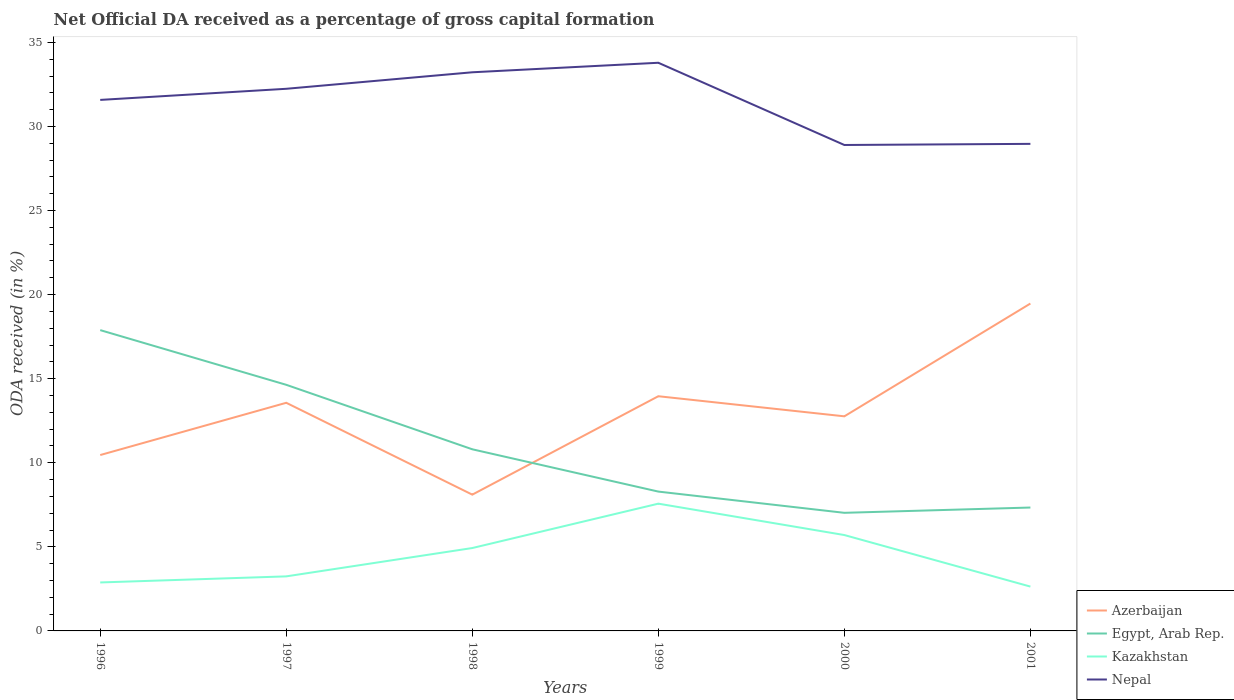Does the line corresponding to Egypt, Arab Rep. intersect with the line corresponding to Nepal?
Keep it short and to the point. No. Across all years, what is the maximum net ODA received in Nepal?
Your answer should be very brief. 28.9. In which year was the net ODA received in Egypt, Arab Rep. maximum?
Offer a very short reply. 2000. What is the total net ODA received in Nepal in the graph?
Your answer should be very brief. -0.57. What is the difference between the highest and the second highest net ODA received in Azerbaijan?
Your answer should be very brief. 11.37. What is the difference between the highest and the lowest net ODA received in Nepal?
Your response must be concise. 4. How many lines are there?
Give a very brief answer. 4. What is the difference between two consecutive major ticks on the Y-axis?
Ensure brevity in your answer.  5. Does the graph contain grids?
Your answer should be very brief. No. How many legend labels are there?
Provide a succinct answer. 4. What is the title of the graph?
Ensure brevity in your answer.  Net Official DA received as a percentage of gross capital formation. What is the label or title of the X-axis?
Ensure brevity in your answer.  Years. What is the label or title of the Y-axis?
Your response must be concise. ODA received (in %). What is the ODA received (in %) in Azerbaijan in 1996?
Your answer should be compact. 10.46. What is the ODA received (in %) in Egypt, Arab Rep. in 1996?
Ensure brevity in your answer.  17.89. What is the ODA received (in %) of Kazakhstan in 1996?
Give a very brief answer. 2.88. What is the ODA received (in %) in Nepal in 1996?
Your answer should be very brief. 31.58. What is the ODA received (in %) in Azerbaijan in 1997?
Provide a short and direct response. 13.57. What is the ODA received (in %) of Egypt, Arab Rep. in 1997?
Your answer should be very brief. 14.64. What is the ODA received (in %) in Kazakhstan in 1997?
Your answer should be very brief. 3.24. What is the ODA received (in %) in Nepal in 1997?
Provide a short and direct response. 32.24. What is the ODA received (in %) of Azerbaijan in 1998?
Your answer should be compact. 8.1. What is the ODA received (in %) in Egypt, Arab Rep. in 1998?
Your answer should be very brief. 10.8. What is the ODA received (in %) in Kazakhstan in 1998?
Provide a succinct answer. 4.93. What is the ODA received (in %) of Nepal in 1998?
Offer a terse response. 33.22. What is the ODA received (in %) in Azerbaijan in 1999?
Provide a succinct answer. 13.96. What is the ODA received (in %) of Egypt, Arab Rep. in 1999?
Your response must be concise. 8.29. What is the ODA received (in %) in Kazakhstan in 1999?
Provide a short and direct response. 7.57. What is the ODA received (in %) of Nepal in 1999?
Keep it short and to the point. 33.79. What is the ODA received (in %) of Azerbaijan in 2000?
Provide a succinct answer. 12.76. What is the ODA received (in %) in Egypt, Arab Rep. in 2000?
Provide a short and direct response. 7.02. What is the ODA received (in %) of Kazakhstan in 2000?
Make the answer very short. 5.7. What is the ODA received (in %) in Nepal in 2000?
Provide a succinct answer. 28.9. What is the ODA received (in %) in Azerbaijan in 2001?
Offer a terse response. 19.47. What is the ODA received (in %) of Egypt, Arab Rep. in 2001?
Provide a succinct answer. 7.34. What is the ODA received (in %) in Kazakhstan in 2001?
Give a very brief answer. 2.64. What is the ODA received (in %) of Nepal in 2001?
Offer a very short reply. 28.97. Across all years, what is the maximum ODA received (in %) in Azerbaijan?
Your answer should be very brief. 19.47. Across all years, what is the maximum ODA received (in %) in Egypt, Arab Rep.?
Your response must be concise. 17.89. Across all years, what is the maximum ODA received (in %) in Kazakhstan?
Your response must be concise. 7.57. Across all years, what is the maximum ODA received (in %) in Nepal?
Your answer should be compact. 33.79. Across all years, what is the minimum ODA received (in %) of Azerbaijan?
Your answer should be very brief. 8.1. Across all years, what is the minimum ODA received (in %) of Egypt, Arab Rep.?
Ensure brevity in your answer.  7.02. Across all years, what is the minimum ODA received (in %) of Kazakhstan?
Your answer should be very brief. 2.64. Across all years, what is the minimum ODA received (in %) of Nepal?
Provide a succinct answer. 28.9. What is the total ODA received (in %) in Azerbaijan in the graph?
Provide a succinct answer. 78.32. What is the total ODA received (in %) in Egypt, Arab Rep. in the graph?
Give a very brief answer. 65.98. What is the total ODA received (in %) of Kazakhstan in the graph?
Ensure brevity in your answer.  26.96. What is the total ODA received (in %) in Nepal in the graph?
Provide a succinct answer. 188.7. What is the difference between the ODA received (in %) in Azerbaijan in 1996 and that in 1997?
Ensure brevity in your answer.  -3.11. What is the difference between the ODA received (in %) of Egypt, Arab Rep. in 1996 and that in 1997?
Your answer should be very brief. 3.25. What is the difference between the ODA received (in %) in Kazakhstan in 1996 and that in 1997?
Provide a succinct answer. -0.36. What is the difference between the ODA received (in %) of Nepal in 1996 and that in 1997?
Make the answer very short. -0.66. What is the difference between the ODA received (in %) in Azerbaijan in 1996 and that in 1998?
Your answer should be very brief. 2.36. What is the difference between the ODA received (in %) of Egypt, Arab Rep. in 1996 and that in 1998?
Make the answer very short. 7.09. What is the difference between the ODA received (in %) of Kazakhstan in 1996 and that in 1998?
Your answer should be compact. -2.05. What is the difference between the ODA received (in %) in Nepal in 1996 and that in 1998?
Provide a succinct answer. -1.64. What is the difference between the ODA received (in %) of Azerbaijan in 1996 and that in 1999?
Make the answer very short. -3.5. What is the difference between the ODA received (in %) in Egypt, Arab Rep. in 1996 and that in 1999?
Make the answer very short. 9.6. What is the difference between the ODA received (in %) in Kazakhstan in 1996 and that in 1999?
Your answer should be very brief. -4.69. What is the difference between the ODA received (in %) of Nepal in 1996 and that in 1999?
Ensure brevity in your answer.  -2.21. What is the difference between the ODA received (in %) of Azerbaijan in 1996 and that in 2000?
Offer a terse response. -2.3. What is the difference between the ODA received (in %) in Egypt, Arab Rep. in 1996 and that in 2000?
Keep it short and to the point. 10.87. What is the difference between the ODA received (in %) of Kazakhstan in 1996 and that in 2000?
Keep it short and to the point. -2.82. What is the difference between the ODA received (in %) in Nepal in 1996 and that in 2000?
Offer a very short reply. 2.68. What is the difference between the ODA received (in %) of Azerbaijan in 1996 and that in 2001?
Your answer should be very brief. -9.01. What is the difference between the ODA received (in %) of Egypt, Arab Rep. in 1996 and that in 2001?
Offer a very short reply. 10.55. What is the difference between the ODA received (in %) of Kazakhstan in 1996 and that in 2001?
Offer a very short reply. 0.25. What is the difference between the ODA received (in %) of Nepal in 1996 and that in 2001?
Make the answer very short. 2.61. What is the difference between the ODA received (in %) of Azerbaijan in 1997 and that in 1998?
Your answer should be very brief. 5.46. What is the difference between the ODA received (in %) of Egypt, Arab Rep. in 1997 and that in 1998?
Offer a terse response. 3.83. What is the difference between the ODA received (in %) in Kazakhstan in 1997 and that in 1998?
Offer a terse response. -1.69. What is the difference between the ODA received (in %) in Nepal in 1997 and that in 1998?
Ensure brevity in your answer.  -0.98. What is the difference between the ODA received (in %) in Azerbaijan in 1997 and that in 1999?
Give a very brief answer. -0.39. What is the difference between the ODA received (in %) in Egypt, Arab Rep. in 1997 and that in 1999?
Your answer should be compact. 6.35. What is the difference between the ODA received (in %) in Kazakhstan in 1997 and that in 1999?
Offer a very short reply. -4.32. What is the difference between the ODA received (in %) of Nepal in 1997 and that in 1999?
Your answer should be very brief. -1.55. What is the difference between the ODA received (in %) of Azerbaijan in 1997 and that in 2000?
Make the answer very short. 0.8. What is the difference between the ODA received (in %) in Egypt, Arab Rep. in 1997 and that in 2000?
Keep it short and to the point. 7.61. What is the difference between the ODA received (in %) in Kazakhstan in 1997 and that in 2000?
Keep it short and to the point. -2.46. What is the difference between the ODA received (in %) of Nepal in 1997 and that in 2000?
Offer a very short reply. 3.34. What is the difference between the ODA received (in %) in Azerbaijan in 1997 and that in 2001?
Your response must be concise. -5.9. What is the difference between the ODA received (in %) of Egypt, Arab Rep. in 1997 and that in 2001?
Keep it short and to the point. 7.3. What is the difference between the ODA received (in %) of Kazakhstan in 1997 and that in 2001?
Keep it short and to the point. 0.61. What is the difference between the ODA received (in %) of Nepal in 1997 and that in 2001?
Ensure brevity in your answer.  3.28. What is the difference between the ODA received (in %) of Azerbaijan in 1998 and that in 1999?
Offer a very short reply. -5.85. What is the difference between the ODA received (in %) of Egypt, Arab Rep. in 1998 and that in 1999?
Make the answer very short. 2.52. What is the difference between the ODA received (in %) of Kazakhstan in 1998 and that in 1999?
Keep it short and to the point. -2.64. What is the difference between the ODA received (in %) of Nepal in 1998 and that in 1999?
Your answer should be very brief. -0.57. What is the difference between the ODA received (in %) in Azerbaijan in 1998 and that in 2000?
Give a very brief answer. -4.66. What is the difference between the ODA received (in %) of Egypt, Arab Rep. in 1998 and that in 2000?
Your response must be concise. 3.78. What is the difference between the ODA received (in %) of Kazakhstan in 1998 and that in 2000?
Offer a terse response. -0.77. What is the difference between the ODA received (in %) in Nepal in 1998 and that in 2000?
Your answer should be very brief. 4.32. What is the difference between the ODA received (in %) of Azerbaijan in 1998 and that in 2001?
Provide a succinct answer. -11.37. What is the difference between the ODA received (in %) in Egypt, Arab Rep. in 1998 and that in 2001?
Your answer should be compact. 3.46. What is the difference between the ODA received (in %) in Kazakhstan in 1998 and that in 2001?
Your response must be concise. 2.29. What is the difference between the ODA received (in %) in Nepal in 1998 and that in 2001?
Your answer should be very brief. 4.26. What is the difference between the ODA received (in %) in Azerbaijan in 1999 and that in 2000?
Ensure brevity in your answer.  1.19. What is the difference between the ODA received (in %) in Egypt, Arab Rep. in 1999 and that in 2000?
Your answer should be very brief. 1.26. What is the difference between the ODA received (in %) in Kazakhstan in 1999 and that in 2000?
Make the answer very short. 1.87. What is the difference between the ODA received (in %) of Nepal in 1999 and that in 2000?
Provide a short and direct response. 4.89. What is the difference between the ODA received (in %) of Azerbaijan in 1999 and that in 2001?
Your response must be concise. -5.51. What is the difference between the ODA received (in %) of Egypt, Arab Rep. in 1999 and that in 2001?
Provide a succinct answer. 0.95. What is the difference between the ODA received (in %) of Kazakhstan in 1999 and that in 2001?
Offer a terse response. 4.93. What is the difference between the ODA received (in %) in Nepal in 1999 and that in 2001?
Provide a short and direct response. 4.82. What is the difference between the ODA received (in %) in Azerbaijan in 2000 and that in 2001?
Your answer should be compact. -6.71. What is the difference between the ODA received (in %) in Egypt, Arab Rep. in 2000 and that in 2001?
Your answer should be compact. -0.31. What is the difference between the ODA received (in %) in Kazakhstan in 2000 and that in 2001?
Offer a terse response. 3.06. What is the difference between the ODA received (in %) of Nepal in 2000 and that in 2001?
Your answer should be very brief. -0.07. What is the difference between the ODA received (in %) of Azerbaijan in 1996 and the ODA received (in %) of Egypt, Arab Rep. in 1997?
Your answer should be compact. -4.18. What is the difference between the ODA received (in %) of Azerbaijan in 1996 and the ODA received (in %) of Kazakhstan in 1997?
Your answer should be compact. 7.22. What is the difference between the ODA received (in %) in Azerbaijan in 1996 and the ODA received (in %) in Nepal in 1997?
Your response must be concise. -21.78. What is the difference between the ODA received (in %) of Egypt, Arab Rep. in 1996 and the ODA received (in %) of Kazakhstan in 1997?
Ensure brevity in your answer.  14.65. What is the difference between the ODA received (in %) of Egypt, Arab Rep. in 1996 and the ODA received (in %) of Nepal in 1997?
Offer a very short reply. -14.35. What is the difference between the ODA received (in %) of Kazakhstan in 1996 and the ODA received (in %) of Nepal in 1997?
Your answer should be compact. -29.36. What is the difference between the ODA received (in %) in Azerbaijan in 1996 and the ODA received (in %) in Egypt, Arab Rep. in 1998?
Offer a terse response. -0.34. What is the difference between the ODA received (in %) in Azerbaijan in 1996 and the ODA received (in %) in Kazakhstan in 1998?
Ensure brevity in your answer.  5.53. What is the difference between the ODA received (in %) in Azerbaijan in 1996 and the ODA received (in %) in Nepal in 1998?
Provide a succinct answer. -22.76. What is the difference between the ODA received (in %) of Egypt, Arab Rep. in 1996 and the ODA received (in %) of Kazakhstan in 1998?
Your answer should be very brief. 12.96. What is the difference between the ODA received (in %) of Egypt, Arab Rep. in 1996 and the ODA received (in %) of Nepal in 1998?
Offer a very short reply. -15.33. What is the difference between the ODA received (in %) of Kazakhstan in 1996 and the ODA received (in %) of Nepal in 1998?
Your response must be concise. -30.34. What is the difference between the ODA received (in %) of Azerbaijan in 1996 and the ODA received (in %) of Egypt, Arab Rep. in 1999?
Your response must be concise. 2.17. What is the difference between the ODA received (in %) in Azerbaijan in 1996 and the ODA received (in %) in Kazakhstan in 1999?
Give a very brief answer. 2.89. What is the difference between the ODA received (in %) of Azerbaijan in 1996 and the ODA received (in %) of Nepal in 1999?
Give a very brief answer. -23.33. What is the difference between the ODA received (in %) in Egypt, Arab Rep. in 1996 and the ODA received (in %) in Kazakhstan in 1999?
Keep it short and to the point. 10.32. What is the difference between the ODA received (in %) in Egypt, Arab Rep. in 1996 and the ODA received (in %) in Nepal in 1999?
Your response must be concise. -15.9. What is the difference between the ODA received (in %) of Kazakhstan in 1996 and the ODA received (in %) of Nepal in 1999?
Ensure brevity in your answer.  -30.91. What is the difference between the ODA received (in %) in Azerbaijan in 1996 and the ODA received (in %) in Egypt, Arab Rep. in 2000?
Your response must be concise. 3.44. What is the difference between the ODA received (in %) of Azerbaijan in 1996 and the ODA received (in %) of Kazakhstan in 2000?
Provide a short and direct response. 4.76. What is the difference between the ODA received (in %) in Azerbaijan in 1996 and the ODA received (in %) in Nepal in 2000?
Your answer should be compact. -18.44. What is the difference between the ODA received (in %) in Egypt, Arab Rep. in 1996 and the ODA received (in %) in Kazakhstan in 2000?
Ensure brevity in your answer.  12.19. What is the difference between the ODA received (in %) of Egypt, Arab Rep. in 1996 and the ODA received (in %) of Nepal in 2000?
Offer a terse response. -11.01. What is the difference between the ODA received (in %) in Kazakhstan in 1996 and the ODA received (in %) in Nepal in 2000?
Offer a very short reply. -26.02. What is the difference between the ODA received (in %) of Azerbaijan in 1996 and the ODA received (in %) of Egypt, Arab Rep. in 2001?
Your response must be concise. 3.12. What is the difference between the ODA received (in %) of Azerbaijan in 1996 and the ODA received (in %) of Kazakhstan in 2001?
Provide a short and direct response. 7.82. What is the difference between the ODA received (in %) in Azerbaijan in 1996 and the ODA received (in %) in Nepal in 2001?
Give a very brief answer. -18.51. What is the difference between the ODA received (in %) of Egypt, Arab Rep. in 1996 and the ODA received (in %) of Kazakhstan in 2001?
Provide a succinct answer. 15.25. What is the difference between the ODA received (in %) in Egypt, Arab Rep. in 1996 and the ODA received (in %) in Nepal in 2001?
Your answer should be compact. -11.08. What is the difference between the ODA received (in %) of Kazakhstan in 1996 and the ODA received (in %) of Nepal in 2001?
Ensure brevity in your answer.  -26.08. What is the difference between the ODA received (in %) of Azerbaijan in 1997 and the ODA received (in %) of Egypt, Arab Rep. in 1998?
Your answer should be compact. 2.77. What is the difference between the ODA received (in %) in Azerbaijan in 1997 and the ODA received (in %) in Kazakhstan in 1998?
Offer a terse response. 8.64. What is the difference between the ODA received (in %) in Azerbaijan in 1997 and the ODA received (in %) in Nepal in 1998?
Your answer should be very brief. -19.66. What is the difference between the ODA received (in %) of Egypt, Arab Rep. in 1997 and the ODA received (in %) of Kazakhstan in 1998?
Give a very brief answer. 9.71. What is the difference between the ODA received (in %) of Egypt, Arab Rep. in 1997 and the ODA received (in %) of Nepal in 1998?
Offer a very short reply. -18.59. What is the difference between the ODA received (in %) of Kazakhstan in 1997 and the ODA received (in %) of Nepal in 1998?
Your answer should be very brief. -29.98. What is the difference between the ODA received (in %) of Azerbaijan in 1997 and the ODA received (in %) of Egypt, Arab Rep. in 1999?
Offer a terse response. 5.28. What is the difference between the ODA received (in %) of Azerbaijan in 1997 and the ODA received (in %) of Kazakhstan in 1999?
Provide a short and direct response. 6. What is the difference between the ODA received (in %) of Azerbaijan in 1997 and the ODA received (in %) of Nepal in 1999?
Offer a very short reply. -20.22. What is the difference between the ODA received (in %) of Egypt, Arab Rep. in 1997 and the ODA received (in %) of Kazakhstan in 1999?
Your answer should be compact. 7.07. What is the difference between the ODA received (in %) of Egypt, Arab Rep. in 1997 and the ODA received (in %) of Nepal in 1999?
Your answer should be compact. -19.15. What is the difference between the ODA received (in %) of Kazakhstan in 1997 and the ODA received (in %) of Nepal in 1999?
Your answer should be compact. -30.55. What is the difference between the ODA received (in %) of Azerbaijan in 1997 and the ODA received (in %) of Egypt, Arab Rep. in 2000?
Make the answer very short. 6.54. What is the difference between the ODA received (in %) of Azerbaijan in 1997 and the ODA received (in %) of Kazakhstan in 2000?
Make the answer very short. 7.87. What is the difference between the ODA received (in %) in Azerbaijan in 1997 and the ODA received (in %) in Nepal in 2000?
Your response must be concise. -15.33. What is the difference between the ODA received (in %) in Egypt, Arab Rep. in 1997 and the ODA received (in %) in Kazakhstan in 2000?
Ensure brevity in your answer.  8.93. What is the difference between the ODA received (in %) of Egypt, Arab Rep. in 1997 and the ODA received (in %) of Nepal in 2000?
Give a very brief answer. -14.26. What is the difference between the ODA received (in %) of Kazakhstan in 1997 and the ODA received (in %) of Nepal in 2000?
Ensure brevity in your answer.  -25.65. What is the difference between the ODA received (in %) in Azerbaijan in 1997 and the ODA received (in %) in Egypt, Arab Rep. in 2001?
Provide a short and direct response. 6.23. What is the difference between the ODA received (in %) in Azerbaijan in 1997 and the ODA received (in %) in Kazakhstan in 2001?
Give a very brief answer. 10.93. What is the difference between the ODA received (in %) of Azerbaijan in 1997 and the ODA received (in %) of Nepal in 2001?
Give a very brief answer. -15.4. What is the difference between the ODA received (in %) in Egypt, Arab Rep. in 1997 and the ODA received (in %) in Kazakhstan in 2001?
Keep it short and to the point. 12. What is the difference between the ODA received (in %) of Egypt, Arab Rep. in 1997 and the ODA received (in %) of Nepal in 2001?
Provide a succinct answer. -14.33. What is the difference between the ODA received (in %) in Kazakhstan in 1997 and the ODA received (in %) in Nepal in 2001?
Give a very brief answer. -25.72. What is the difference between the ODA received (in %) in Azerbaijan in 1998 and the ODA received (in %) in Egypt, Arab Rep. in 1999?
Your answer should be very brief. -0.18. What is the difference between the ODA received (in %) of Azerbaijan in 1998 and the ODA received (in %) of Kazakhstan in 1999?
Keep it short and to the point. 0.54. What is the difference between the ODA received (in %) in Azerbaijan in 1998 and the ODA received (in %) in Nepal in 1999?
Provide a short and direct response. -25.68. What is the difference between the ODA received (in %) of Egypt, Arab Rep. in 1998 and the ODA received (in %) of Kazakhstan in 1999?
Give a very brief answer. 3.23. What is the difference between the ODA received (in %) in Egypt, Arab Rep. in 1998 and the ODA received (in %) in Nepal in 1999?
Give a very brief answer. -22.99. What is the difference between the ODA received (in %) of Kazakhstan in 1998 and the ODA received (in %) of Nepal in 1999?
Give a very brief answer. -28.86. What is the difference between the ODA received (in %) of Azerbaijan in 1998 and the ODA received (in %) of Egypt, Arab Rep. in 2000?
Offer a terse response. 1.08. What is the difference between the ODA received (in %) of Azerbaijan in 1998 and the ODA received (in %) of Kazakhstan in 2000?
Your response must be concise. 2.4. What is the difference between the ODA received (in %) of Azerbaijan in 1998 and the ODA received (in %) of Nepal in 2000?
Your answer should be compact. -20.79. What is the difference between the ODA received (in %) in Egypt, Arab Rep. in 1998 and the ODA received (in %) in Kazakhstan in 2000?
Your answer should be compact. 5.1. What is the difference between the ODA received (in %) in Egypt, Arab Rep. in 1998 and the ODA received (in %) in Nepal in 2000?
Your answer should be compact. -18.1. What is the difference between the ODA received (in %) in Kazakhstan in 1998 and the ODA received (in %) in Nepal in 2000?
Offer a terse response. -23.97. What is the difference between the ODA received (in %) of Azerbaijan in 1998 and the ODA received (in %) of Egypt, Arab Rep. in 2001?
Provide a short and direct response. 0.77. What is the difference between the ODA received (in %) in Azerbaijan in 1998 and the ODA received (in %) in Kazakhstan in 2001?
Provide a short and direct response. 5.47. What is the difference between the ODA received (in %) in Azerbaijan in 1998 and the ODA received (in %) in Nepal in 2001?
Make the answer very short. -20.86. What is the difference between the ODA received (in %) in Egypt, Arab Rep. in 1998 and the ODA received (in %) in Kazakhstan in 2001?
Your answer should be compact. 8.16. What is the difference between the ODA received (in %) of Egypt, Arab Rep. in 1998 and the ODA received (in %) of Nepal in 2001?
Your response must be concise. -18.16. What is the difference between the ODA received (in %) in Kazakhstan in 1998 and the ODA received (in %) in Nepal in 2001?
Provide a short and direct response. -24.04. What is the difference between the ODA received (in %) in Azerbaijan in 1999 and the ODA received (in %) in Egypt, Arab Rep. in 2000?
Offer a terse response. 6.93. What is the difference between the ODA received (in %) in Azerbaijan in 1999 and the ODA received (in %) in Kazakhstan in 2000?
Your answer should be compact. 8.26. What is the difference between the ODA received (in %) of Azerbaijan in 1999 and the ODA received (in %) of Nepal in 2000?
Give a very brief answer. -14.94. What is the difference between the ODA received (in %) in Egypt, Arab Rep. in 1999 and the ODA received (in %) in Kazakhstan in 2000?
Your response must be concise. 2.58. What is the difference between the ODA received (in %) of Egypt, Arab Rep. in 1999 and the ODA received (in %) of Nepal in 2000?
Your response must be concise. -20.61. What is the difference between the ODA received (in %) in Kazakhstan in 1999 and the ODA received (in %) in Nepal in 2000?
Offer a terse response. -21.33. What is the difference between the ODA received (in %) in Azerbaijan in 1999 and the ODA received (in %) in Egypt, Arab Rep. in 2001?
Give a very brief answer. 6.62. What is the difference between the ODA received (in %) of Azerbaijan in 1999 and the ODA received (in %) of Kazakhstan in 2001?
Offer a very short reply. 11.32. What is the difference between the ODA received (in %) in Azerbaijan in 1999 and the ODA received (in %) in Nepal in 2001?
Your response must be concise. -15.01. What is the difference between the ODA received (in %) of Egypt, Arab Rep. in 1999 and the ODA received (in %) of Kazakhstan in 2001?
Provide a short and direct response. 5.65. What is the difference between the ODA received (in %) in Egypt, Arab Rep. in 1999 and the ODA received (in %) in Nepal in 2001?
Offer a terse response. -20.68. What is the difference between the ODA received (in %) of Kazakhstan in 1999 and the ODA received (in %) of Nepal in 2001?
Give a very brief answer. -21.4. What is the difference between the ODA received (in %) of Azerbaijan in 2000 and the ODA received (in %) of Egypt, Arab Rep. in 2001?
Your answer should be compact. 5.42. What is the difference between the ODA received (in %) in Azerbaijan in 2000 and the ODA received (in %) in Kazakhstan in 2001?
Offer a very short reply. 10.13. What is the difference between the ODA received (in %) of Azerbaijan in 2000 and the ODA received (in %) of Nepal in 2001?
Make the answer very short. -16.2. What is the difference between the ODA received (in %) of Egypt, Arab Rep. in 2000 and the ODA received (in %) of Kazakhstan in 2001?
Ensure brevity in your answer.  4.39. What is the difference between the ODA received (in %) of Egypt, Arab Rep. in 2000 and the ODA received (in %) of Nepal in 2001?
Offer a very short reply. -21.94. What is the difference between the ODA received (in %) in Kazakhstan in 2000 and the ODA received (in %) in Nepal in 2001?
Provide a succinct answer. -23.26. What is the average ODA received (in %) in Azerbaijan per year?
Offer a terse response. 13.05. What is the average ODA received (in %) in Egypt, Arab Rep. per year?
Offer a very short reply. 11. What is the average ODA received (in %) of Kazakhstan per year?
Keep it short and to the point. 4.49. What is the average ODA received (in %) in Nepal per year?
Make the answer very short. 31.45. In the year 1996, what is the difference between the ODA received (in %) in Azerbaijan and ODA received (in %) in Egypt, Arab Rep.?
Make the answer very short. -7.43. In the year 1996, what is the difference between the ODA received (in %) of Azerbaijan and ODA received (in %) of Kazakhstan?
Make the answer very short. 7.58. In the year 1996, what is the difference between the ODA received (in %) in Azerbaijan and ODA received (in %) in Nepal?
Your answer should be very brief. -21.12. In the year 1996, what is the difference between the ODA received (in %) of Egypt, Arab Rep. and ODA received (in %) of Kazakhstan?
Offer a very short reply. 15.01. In the year 1996, what is the difference between the ODA received (in %) in Egypt, Arab Rep. and ODA received (in %) in Nepal?
Your answer should be compact. -13.69. In the year 1996, what is the difference between the ODA received (in %) in Kazakhstan and ODA received (in %) in Nepal?
Provide a short and direct response. -28.7. In the year 1997, what is the difference between the ODA received (in %) of Azerbaijan and ODA received (in %) of Egypt, Arab Rep.?
Your answer should be very brief. -1.07. In the year 1997, what is the difference between the ODA received (in %) of Azerbaijan and ODA received (in %) of Kazakhstan?
Offer a terse response. 10.32. In the year 1997, what is the difference between the ODA received (in %) in Azerbaijan and ODA received (in %) in Nepal?
Keep it short and to the point. -18.67. In the year 1997, what is the difference between the ODA received (in %) in Egypt, Arab Rep. and ODA received (in %) in Kazakhstan?
Your answer should be very brief. 11.39. In the year 1997, what is the difference between the ODA received (in %) of Egypt, Arab Rep. and ODA received (in %) of Nepal?
Make the answer very short. -17.61. In the year 1997, what is the difference between the ODA received (in %) of Kazakhstan and ODA received (in %) of Nepal?
Make the answer very short. -29. In the year 1998, what is the difference between the ODA received (in %) of Azerbaijan and ODA received (in %) of Egypt, Arab Rep.?
Your response must be concise. -2.7. In the year 1998, what is the difference between the ODA received (in %) in Azerbaijan and ODA received (in %) in Kazakhstan?
Provide a succinct answer. 3.18. In the year 1998, what is the difference between the ODA received (in %) of Azerbaijan and ODA received (in %) of Nepal?
Provide a short and direct response. -25.12. In the year 1998, what is the difference between the ODA received (in %) of Egypt, Arab Rep. and ODA received (in %) of Kazakhstan?
Provide a succinct answer. 5.87. In the year 1998, what is the difference between the ODA received (in %) of Egypt, Arab Rep. and ODA received (in %) of Nepal?
Offer a very short reply. -22.42. In the year 1998, what is the difference between the ODA received (in %) in Kazakhstan and ODA received (in %) in Nepal?
Your response must be concise. -28.29. In the year 1999, what is the difference between the ODA received (in %) in Azerbaijan and ODA received (in %) in Egypt, Arab Rep.?
Offer a very short reply. 5.67. In the year 1999, what is the difference between the ODA received (in %) of Azerbaijan and ODA received (in %) of Kazakhstan?
Make the answer very short. 6.39. In the year 1999, what is the difference between the ODA received (in %) in Azerbaijan and ODA received (in %) in Nepal?
Offer a terse response. -19.83. In the year 1999, what is the difference between the ODA received (in %) in Egypt, Arab Rep. and ODA received (in %) in Kazakhstan?
Ensure brevity in your answer.  0.72. In the year 1999, what is the difference between the ODA received (in %) of Egypt, Arab Rep. and ODA received (in %) of Nepal?
Offer a terse response. -25.5. In the year 1999, what is the difference between the ODA received (in %) in Kazakhstan and ODA received (in %) in Nepal?
Keep it short and to the point. -26.22. In the year 2000, what is the difference between the ODA received (in %) of Azerbaijan and ODA received (in %) of Egypt, Arab Rep.?
Provide a succinct answer. 5.74. In the year 2000, what is the difference between the ODA received (in %) of Azerbaijan and ODA received (in %) of Kazakhstan?
Your answer should be compact. 7.06. In the year 2000, what is the difference between the ODA received (in %) in Azerbaijan and ODA received (in %) in Nepal?
Provide a short and direct response. -16.14. In the year 2000, what is the difference between the ODA received (in %) in Egypt, Arab Rep. and ODA received (in %) in Kazakhstan?
Give a very brief answer. 1.32. In the year 2000, what is the difference between the ODA received (in %) in Egypt, Arab Rep. and ODA received (in %) in Nepal?
Keep it short and to the point. -21.88. In the year 2000, what is the difference between the ODA received (in %) of Kazakhstan and ODA received (in %) of Nepal?
Offer a very short reply. -23.2. In the year 2001, what is the difference between the ODA received (in %) of Azerbaijan and ODA received (in %) of Egypt, Arab Rep.?
Keep it short and to the point. 12.13. In the year 2001, what is the difference between the ODA received (in %) in Azerbaijan and ODA received (in %) in Kazakhstan?
Provide a short and direct response. 16.83. In the year 2001, what is the difference between the ODA received (in %) of Azerbaijan and ODA received (in %) of Nepal?
Offer a very short reply. -9.5. In the year 2001, what is the difference between the ODA received (in %) of Egypt, Arab Rep. and ODA received (in %) of Kazakhstan?
Make the answer very short. 4.7. In the year 2001, what is the difference between the ODA received (in %) of Egypt, Arab Rep. and ODA received (in %) of Nepal?
Offer a very short reply. -21.63. In the year 2001, what is the difference between the ODA received (in %) in Kazakhstan and ODA received (in %) in Nepal?
Offer a terse response. -26.33. What is the ratio of the ODA received (in %) in Azerbaijan in 1996 to that in 1997?
Provide a short and direct response. 0.77. What is the ratio of the ODA received (in %) in Egypt, Arab Rep. in 1996 to that in 1997?
Provide a short and direct response. 1.22. What is the ratio of the ODA received (in %) in Kazakhstan in 1996 to that in 1997?
Give a very brief answer. 0.89. What is the ratio of the ODA received (in %) of Nepal in 1996 to that in 1997?
Make the answer very short. 0.98. What is the ratio of the ODA received (in %) in Azerbaijan in 1996 to that in 1998?
Provide a succinct answer. 1.29. What is the ratio of the ODA received (in %) of Egypt, Arab Rep. in 1996 to that in 1998?
Offer a terse response. 1.66. What is the ratio of the ODA received (in %) of Kazakhstan in 1996 to that in 1998?
Offer a terse response. 0.58. What is the ratio of the ODA received (in %) in Nepal in 1996 to that in 1998?
Provide a succinct answer. 0.95. What is the ratio of the ODA received (in %) in Azerbaijan in 1996 to that in 1999?
Offer a terse response. 0.75. What is the ratio of the ODA received (in %) of Egypt, Arab Rep. in 1996 to that in 1999?
Keep it short and to the point. 2.16. What is the ratio of the ODA received (in %) in Kazakhstan in 1996 to that in 1999?
Give a very brief answer. 0.38. What is the ratio of the ODA received (in %) of Nepal in 1996 to that in 1999?
Your response must be concise. 0.93. What is the ratio of the ODA received (in %) of Azerbaijan in 1996 to that in 2000?
Make the answer very short. 0.82. What is the ratio of the ODA received (in %) in Egypt, Arab Rep. in 1996 to that in 2000?
Offer a terse response. 2.55. What is the ratio of the ODA received (in %) in Kazakhstan in 1996 to that in 2000?
Ensure brevity in your answer.  0.51. What is the ratio of the ODA received (in %) of Nepal in 1996 to that in 2000?
Ensure brevity in your answer.  1.09. What is the ratio of the ODA received (in %) in Azerbaijan in 1996 to that in 2001?
Ensure brevity in your answer.  0.54. What is the ratio of the ODA received (in %) in Egypt, Arab Rep. in 1996 to that in 2001?
Keep it short and to the point. 2.44. What is the ratio of the ODA received (in %) in Kazakhstan in 1996 to that in 2001?
Your answer should be very brief. 1.09. What is the ratio of the ODA received (in %) of Nepal in 1996 to that in 2001?
Offer a terse response. 1.09. What is the ratio of the ODA received (in %) in Azerbaijan in 1997 to that in 1998?
Your answer should be very brief. 1.67. What is the ratio of the ODA received (in %) of Egypt, Arab Rep. in 1997 to that in 1998?
Offer a very short reply. 1.35. What is the ratio of the ODA received (in %) of Kazakhstan in 1997 to that in 1998?
Give a very brief answer. 0.66. What is the ratio of the ODA received (in %) of Nepal in 1997 to that in 1998?
Your response must be concise. 0.97. What is the ratio of the ODA received (in %) in Azerbaijan in 1997 to that in 1999?
Your answer should be compact. 0.97. What is the ratio of the ODA received (in %) in Egypt, Arab Rep. in 1997 to that in 1999?
Keep it short and to the point. 1.77. What is the ratio of the ODA received (in %) of Kazakhstan in 1997 to that in 1999?
Your answer should be compact. 0.43. What is the ratio of the ODA received (in %) in Nepal in 1997 to that in 1999?
Offer a terse response. 0.95. What is the ratio of the ODA received (in %) in Azerbaijan in 1997 to that in 2000?
Offer a terse response. 1.06. What is the ratio of the ODA received (in %) of Egypt, Arab Rep. in 1997 to that in 2000?
Keep it short and to the point. 2.08. What is the ratio of the ODA received (in %) in Kazakhstan in 1997 to that in 2000?
Offer a very short reply. 0.57. What is the ratio of the ODA received (in %) in Nepal in 1997 to that in 2000?
Provide a short and direct response. 1.12. What is the ratio of the ODA received (in %) of Azerbaijan in 1997 to that in 2001?
Provide a short and direct response. 0.7. What is the ratio of the ODA received (in %) of Egypt, Arab Rep. in 1997 to that in 2001?
Make the answer very short. 1.99. What is the ratio of the ODA received (in %) of Kazakhstan in 1997 to that in 2001?
Ensure brevity in your answer.  1.23. What is the ratio of the ODA received (in %) in Nepal in 1997 to that in 2001?
Your response must be concise. 1.11. What is the ratio of the ODA received (in %) in Azerbaijan in 1998 to that in 1999?
Your response must be concise. 0.58. What is the ratio of the ODA received (in %) of Egypt, Arab Rep. in 1998 to that in 1999?
Keep it short and to the point. 1.3. What is the ratio of the ODA received (in %) of Kazakhstan in 1998 to that in 1999?
Provide a succinct answer. 0.65. What is the ratio of the ODA received (in %) of Nepal in 1998 to that in 1999?
Your response must be concise. 0.98. What is the ratio of the ODA received (in %) in Azerbaijan in 1998 to that in 2000?
Offer a very short reply. 0.64. What is the ratio of the ODA received (in %) of Egypt, Arab Rep. in 1998 to that in 2000?
Provide a short and direct response. 1.54. What is the ratio of the ODA received (in %) of Kazakhstan in 1998 to that in 2000?
Provide a succinct answer. 0.86. What is the ratio of the ODA received (in %) of Nepal in 1998 to that in 2000?
Provide a succinct answer. 1.15. What is the ratio of the ODA received (in %) of Azerbaijan in 1998 to that in 2001?
Provide a succinct answer. 0.42. What is the ratio of the ODA received (in %) in Egypt, Arab Rep. in 1998 to that in 2001?
Your answer should be very brief. 1.47. What is the ratio of the ODA received (in %) of Kazakhstan in 1998 to that in 2001?
Your answer should be compact. 1.87. What is the ratio of the ODA received (in %) of Nepal in 1998 to that in 2001?
Your answer should be very brief. 1.15. What is the ratio of the ODA received (in %) in Azerbaijan in 1999 to that in 2000?
Your response must be concise. 1.09. What is the ratio of the ODA received (in %) of Egypt, Arab Rep. in 1999 to that in 2000?
Your answer should be compact. 1.18. What is the ratio of the ODA received (in %) of Kazakhstan in 1999 to that in 2000?
Make the answer very short. 1.33. What is the ratio of the ODA received (in %) of Nepal in 1999 to that in 2000?
Offer a terse response. 1.17. What is the ratio of the ODA received (in %) in Azerbaijan in 1999 to that in 2001?
Provide a succinct answer. 0.72. What is the ratio of the ODA received (in %) in Egypt, Arab Rep. in 1999 to that in 2001?
Provide a short and direct response. 1.13. What is the ratio of the ODA received (in %) in Kazakhstan in 1999 to that in 2001?
Ensure brevity in your answer.  2.87. What is the ratio of the ODA received (in %) of Nepal in 1999 to that in 2001?
Your answer should be very brief. 1.17. What is the ratio of the ODA received (in %) in Azerbaijan in 2000 to that in 2001?
Make the answer very short. 0.66. What is the ratio of the ODA received (in %) of Egypt, Arab Rep. in 2000 to that in 2001?
Keep it short and to the point. 0.96. What is the ratio of the ODA received (in %) in Kazakhstan in 2000 to that in 2001?
Keep it short and to the point. 2.16. What is the difference between the highest and the second highest ODA received (in %) of Azerbaijan?
Give a very brief answer. 5.51. What is the difference between the highest and the second highest ODA received (in %) of Egypt, Arab Rep.?
Ensure brevity in your answer.  3.25. What is the difference between the highest and the second highest ODA received (in %) of Kazakhstan?
Provide a short and direct response. 1.87. What is the difference between the highest and the second highest ODA received (in %) of Nepal?
Your answer should be compact. 0.57. What is the difference between the highest and the lowest ODA received (in %) in Azerbaijan?
Provide a short and direct response. 11.37. What is the difference between the highest and the lowest ODA received (in %) of Egypt, Arab Rep.?
Your answer should be very brief. 10.87. What is the difference between the highest and the lowest ODA received (in %) of Kazakhstan?
Offer a very short reply. 4.93. What is the difference between the highest and the lowest ODA received (in %) of Nepal?
Make the answer very short. 4.89. 